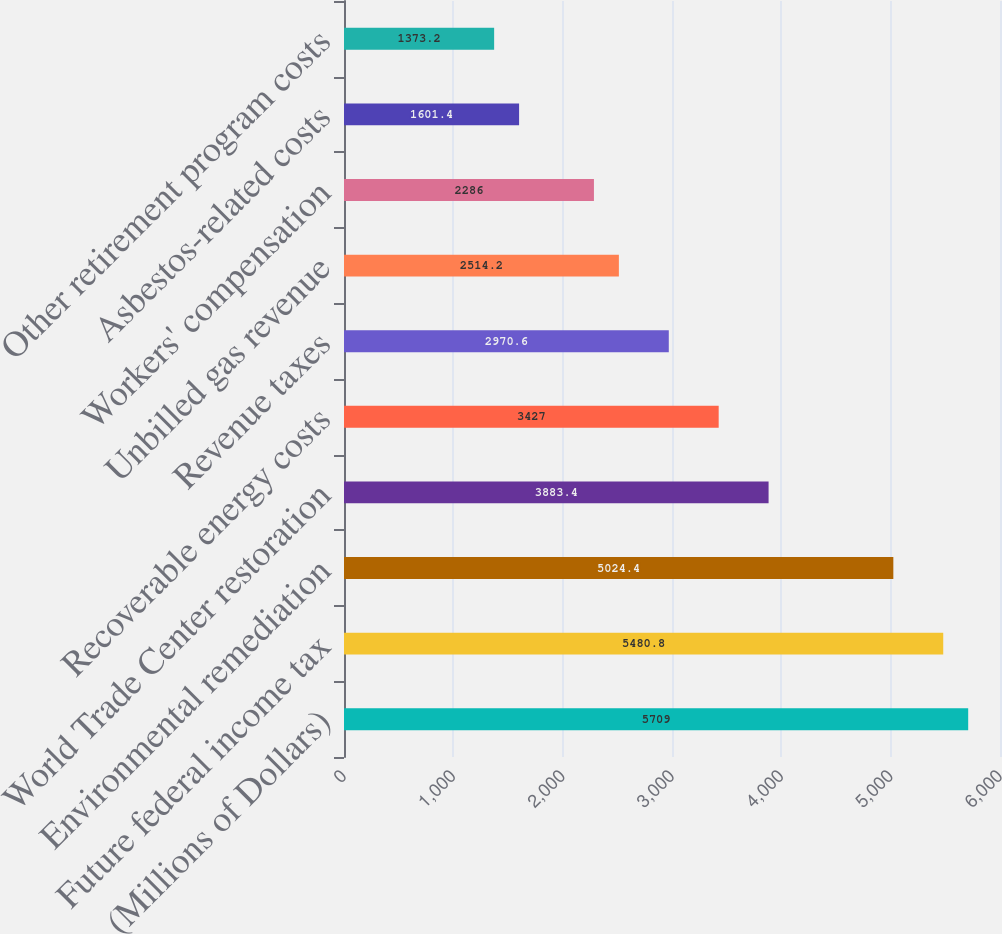<chart> <loc_0><loc_0><loc_500><loc_500><bar_chart><fcel>(Millions of Dollars)<fcel>Future federal income tax<fcel>Environmental remediation<fcel>World Trade Center restoration<fcel>Recoverable energy costs<fcel>Revenue taxes<fcel>Unbilled gas revenue<fcel>Workers' compensation<fcel>Asbestos-related costs<fcel>Other retirement program costs<nl><fcel>5709<fcel>5480.8<fcel>5024.4<fcel>3883.4<fcel>3427<fcel>2970.6<fcel>2514.2<fcel>2286<fcel>1601.4<fcel>1373.2<nl></chart> 